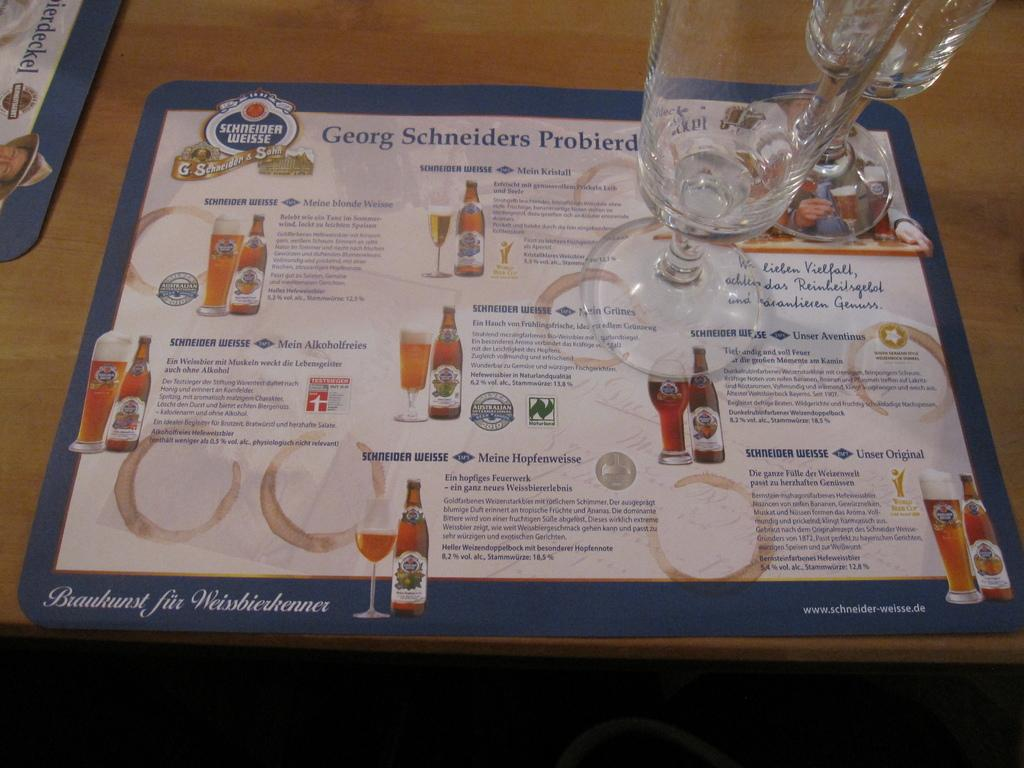<image>
Present a compact description of the photo's key features. a paper sitting underneath some glasses that says 'georg schneiders probierd' at the top 